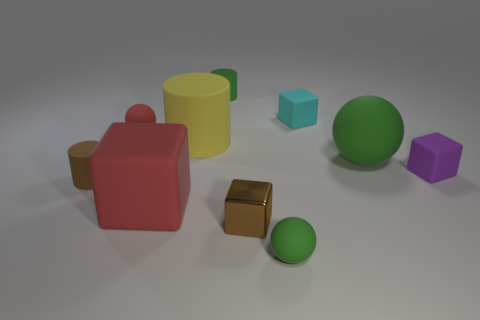Subtract all cylinders. How many objects are left? 7 Subtract 0 purple balls. How many objects are left? 10 Subtract all big green matte spheres. Subtract all cylinders. How many objects are left? 6 Add 5 small green matte cylinders. How many small green matte cylinders are left? 6 Add 5 green cylinders. How many green cylinders exist? 6 